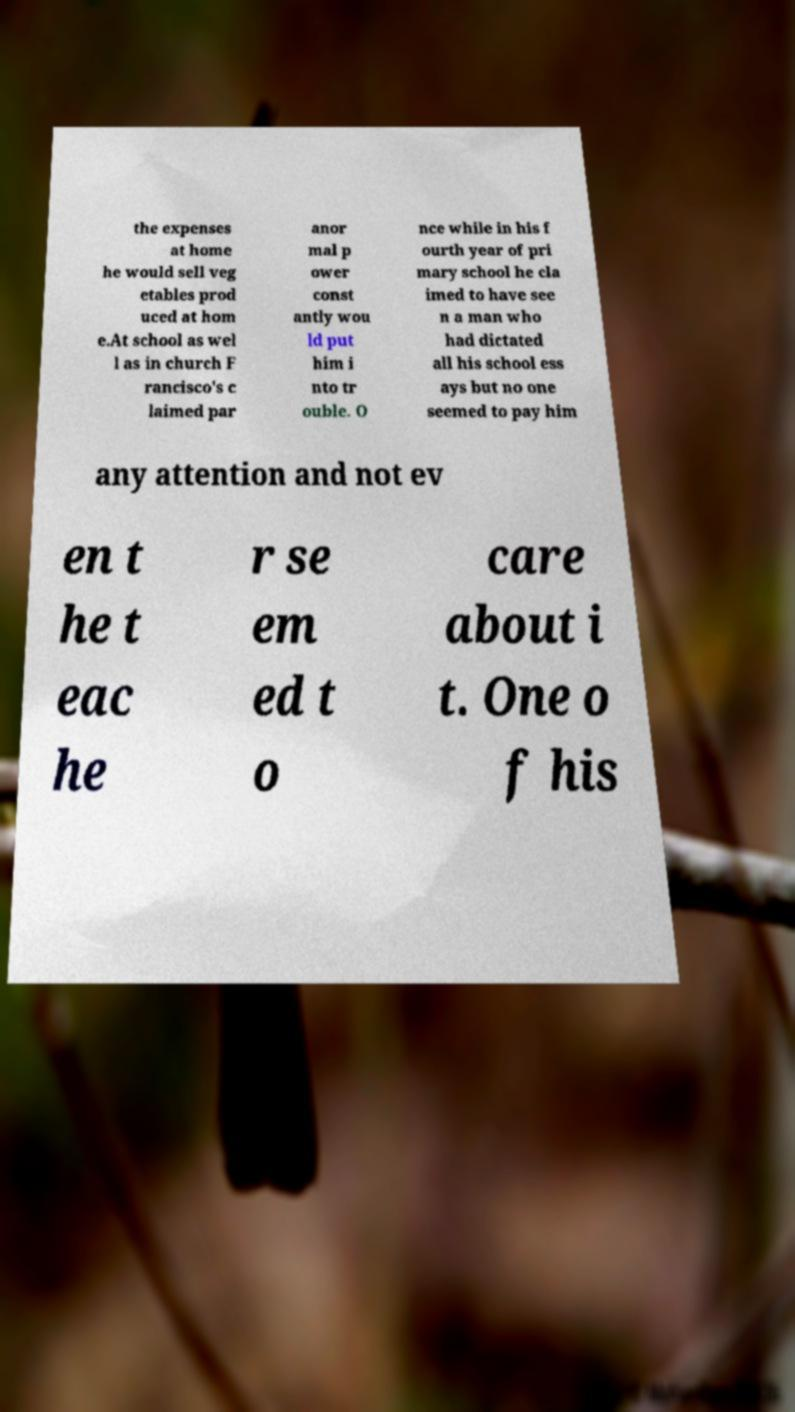Can you read and provide the text displayed in the image?This photo seems to have some interesting text. Can you extract and type it out for me? the expenses at home he would sell veg etables prod uced at hom e.At school as wel l as in church F rancisco's c laimed par anor mal p ower const antly wou ld put him i nto tr ouble. O nce while in his f ourth year of pri mary school he cla imed to have see n a man who had dictated all his school ess ays but no one seemed to pay him any attention and not ev en t he t eac he r se em ed t o care about i t. One o f his 